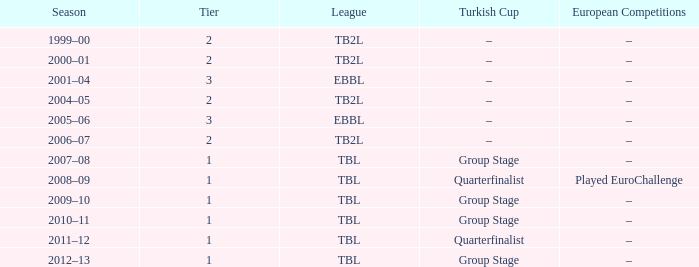In the 2000-01 season, what are the european competitions classified as tier 2? –. 